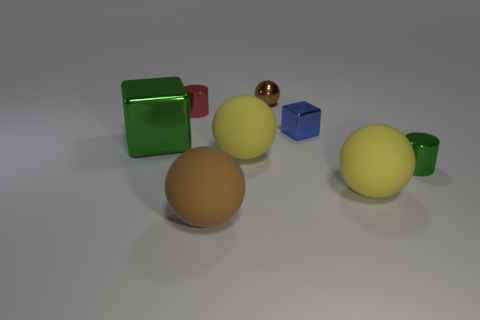Subtract all shiny balls. How many balls are left? 3 Add 2 brown spheres. How many objects exist? 10 Subtract all yellow balls. How many balls are left? 2 Subtract all green objects. Subtract all shiny cylinders. How many objects are left? 4 Add 2 tiny spheres. How many tiny spheres are left? 3 Add 5 tiny cylinders. How many tiny cylinders exist? 7 Subtract 0 brown blocks. How many objects are left? 8 Subtract all cubes. How many objects are left? 6 Subtract 2 cylinders. How many cylinders are left? 0 Subtract all yellow spheres. Subtract all green blocks. How many spheres are left? 2 